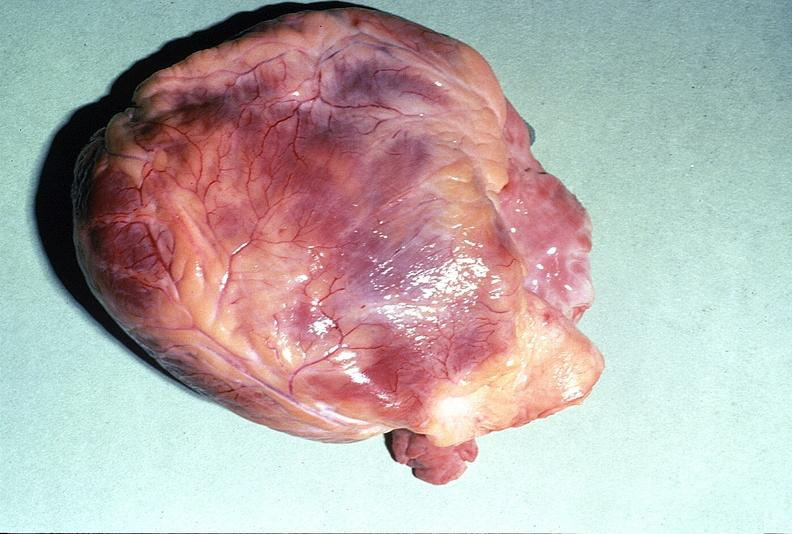does this image show normal cardiovascular?
Answer the question using a single word or phrase. Yes 